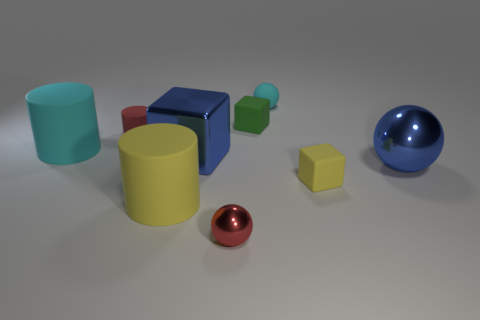There is a cyan matte thing behind the small cylinder; is its shape the same as the big shiny thing right of the small rubber sphere?
Your answer should be compact. Yes. What color is the large object that is in front of the big blue block and to the left of the blue metal cube?
Offer a terse response. Yellow. There is a tiny shiny thing; does it have the same color as the small matte thing that is left of the tiny green matte cube?
Offer a terse response. Yes. What is the size of the rubber cylinder that is behind the blue metal block and in front of the red rubber cylinder?
Offer a very short reply. Large. There is a cyan matte object that is left of the large rubber thing in front of the large blue object on the right side of the tiny red ball; what size is it?
Provide a succinct answer. Large. Are there any tiny red rubber cylinders left of the small cyan matte thing?
Your answer should be very brief. Yes. There is a red matte thing; is its size the same as the blue object behind the large ball?
Offer a very short reply. No. What number of other objects are there of the same material as the big yellow thing?
Provide a short and direct response. 5. There is a small object that is both in front of the red cylinder and left of the small green block; what shape is it?
Offer a terse response. Sphere. Does the cyan object to the right of the small shiny sphere have the same size as the blue shiny thing that is behind the big sphere?
Make the answer very short. No. 